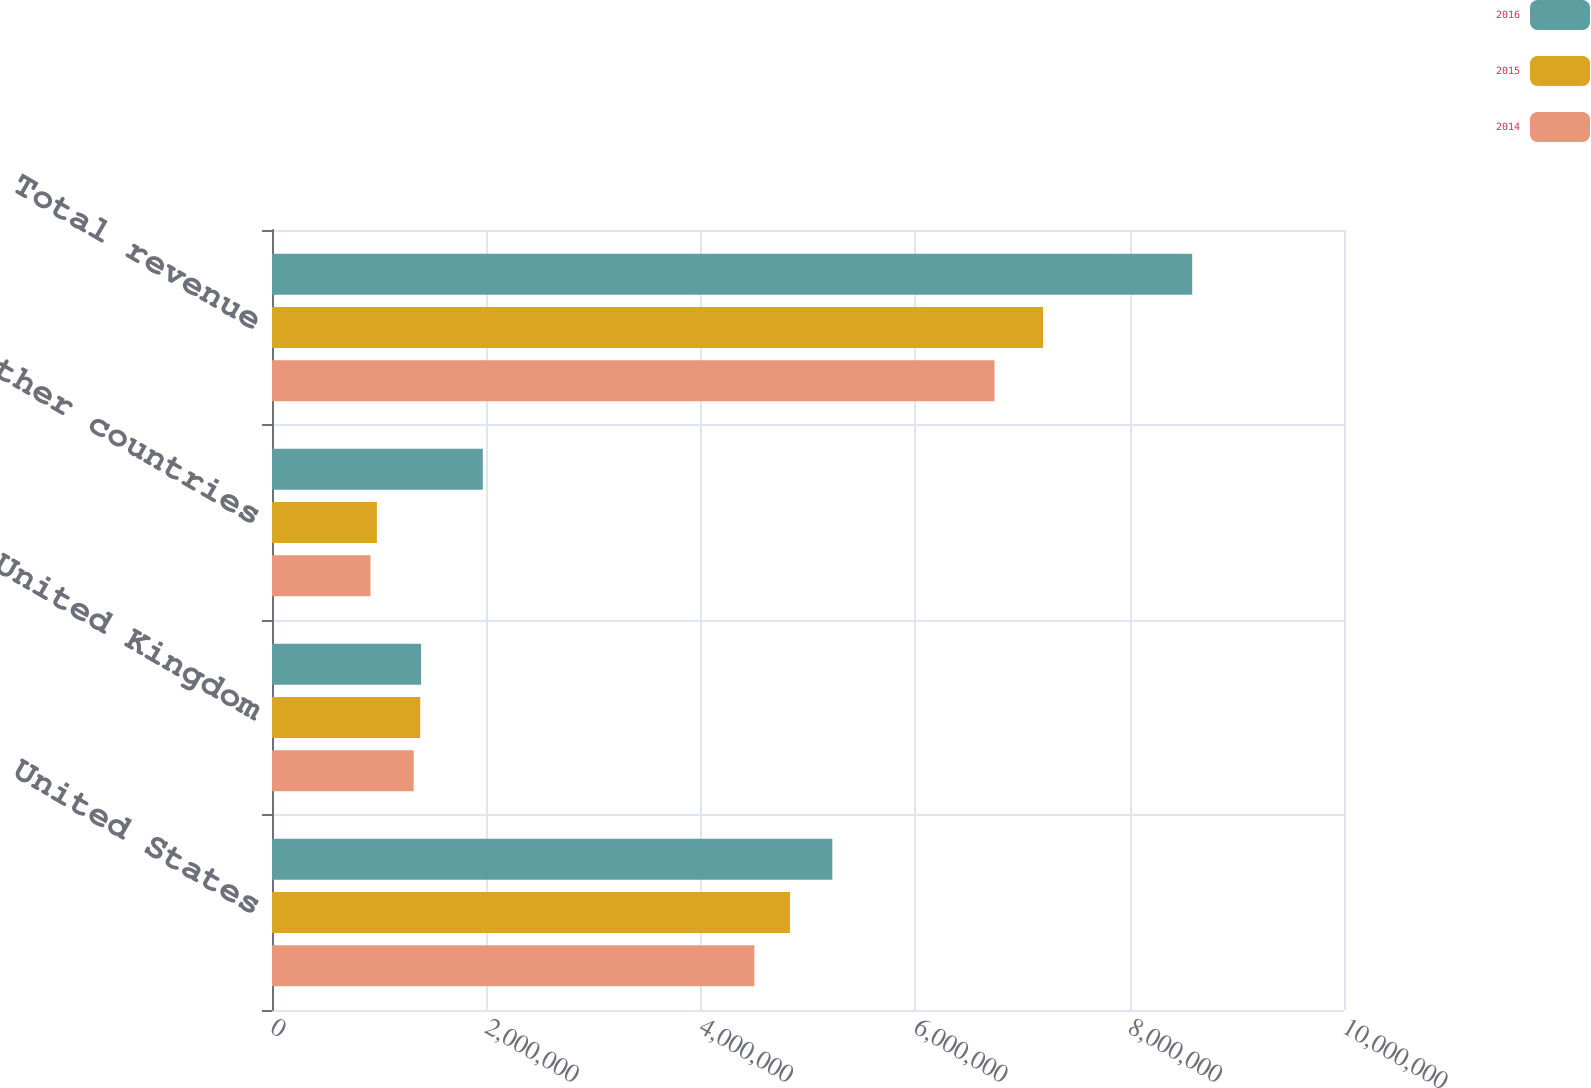Convert chart. <chart><loc_0><loc_0><loc_500><loc_500><stacked_bar_chart><ecel><fcel>United States<fcel>United Kingdom<fcel>Other countries<fcel>Total revenue<nl><fcel>2016<fcel>5.22692e+06<fcel>1.39078e+06<fcel>1.96634e+06<fcel>8.58403e+06<nl><fcel>2015<fcel>4.83188e+06<fcel>1.38243e+06<fcel>978326<fcel>7.19263e+06<nl><fcel>2014<fcel>4.49974e+06<fcel>1.32179e+06<fcel>918535<fcel>6.74006e+06<nl></chart> 